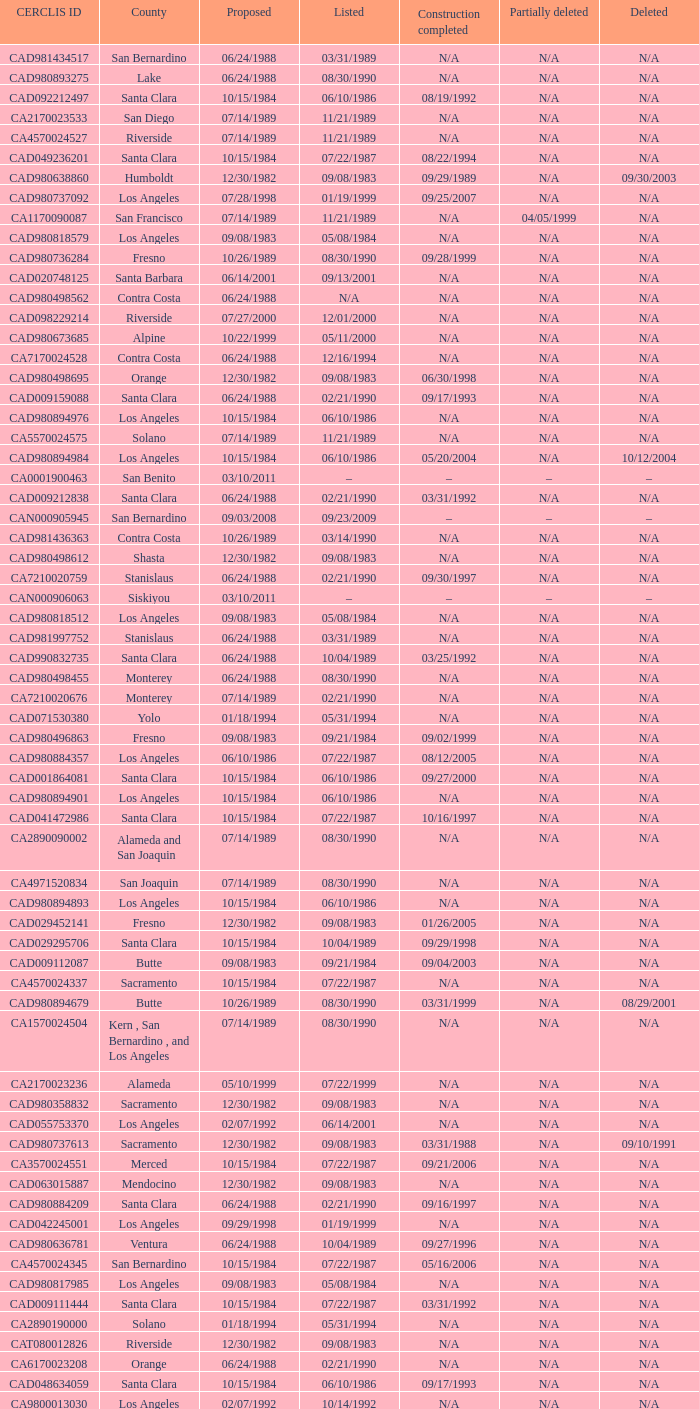What construction completed on 08/10/2007? 07/22/1987. 